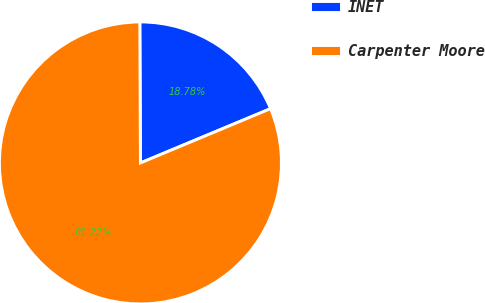<chart> <loc_0><loc_0><loc_500><loc_500><pie_chart><fcel>INET<fcel>Carpenter Moore<nl><fcel>18.78%<fcel>81.22%<nl></chart> 